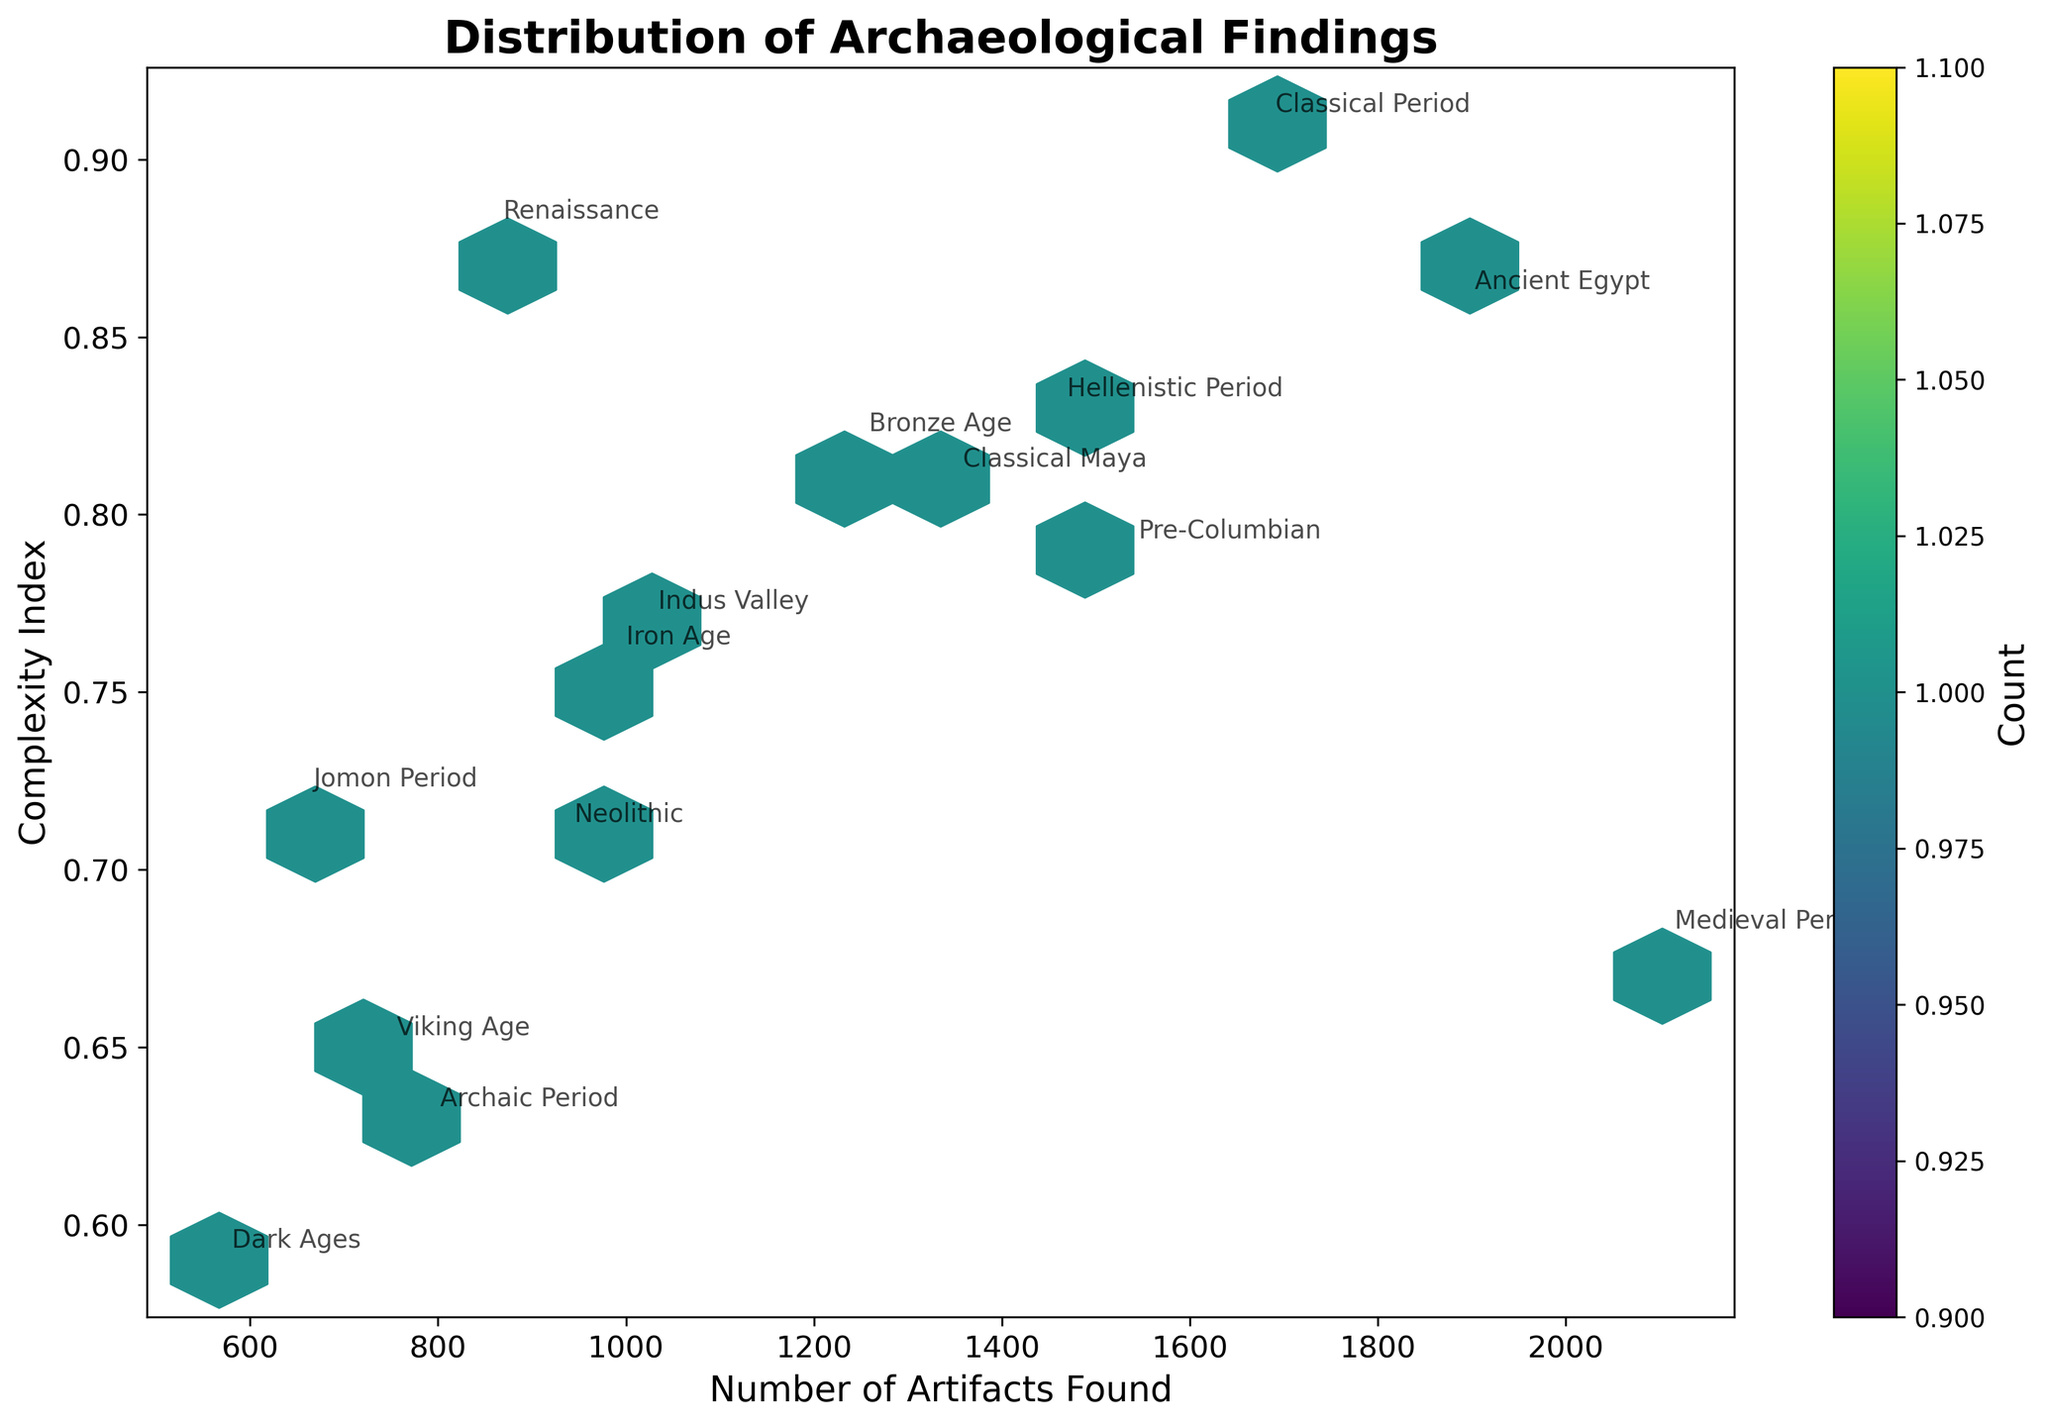What is the title of the plot? The title is located at the top center of the plot, which provides a summary of the figure.
Answer: Distribution of Archaeological Findings How many geographical regions are represented in the plot? Each era has a corresponding region, and since eras are annotated on the plot, counting the annotations will give the number of regions.
Answer: 15 Which era has the highest number of artifacts found? By locating the highest point on the x-axis (Number of Artifacts Found) with corresponding annotations, we find the era.
Answer: Medieval Period Which era has the lowest complexity index? By finding the lowest point on the y-axis (Complexity Index) with corresponding annotations, we identify the era.
Answer: Dark Ages What is the range of the number of artifacts found? By looking at the x-axis, identify the minimum and maximum values and subtract the minimum from the maximum. The range is the difference between these two values.
Answer: 567 to 2103 Which regions have more than 1500 artifacts found but a complexity index less than 0.9? Locate the data points where x > 1500 (artifacts) and y < 0.9 (complexity index), then read their corresponding annotations.
Answer: Medieval Period, Pre-Columbian Compare the complexity indices of Ancient Egypt and Renaissance. Which one is higher? Locate the annotations for Ancient Egypt and Renaissance on the plot and compare their y-values (Complexity Index).
Answer: Ancient Egypt What is the most common range for the number of artifacts found? Observe the hexbin plot's color intensity and the color bar. The densest area with the highest count indicates the common range.
Answer: 900 to 1700 Are there more instances of high complexity or low complexity artifacts? Compare the density of hexagons in the upper y-values (high complexity) vs. lower y-values (low complexity) regions, as indicated by the hexbin plot's color.
Answer: High complexity From the plot, which era had similar artifacts found and complexity index as the Iron Age? Find the annotation point for Iron Age, then look for another point close to it in terms of x (artifacts) and y (complexity index).
Answer: Neolithic 